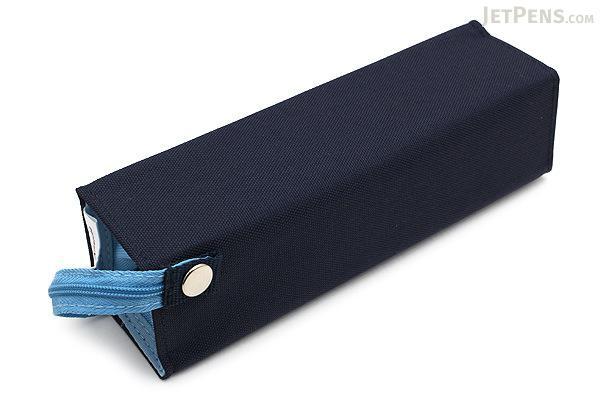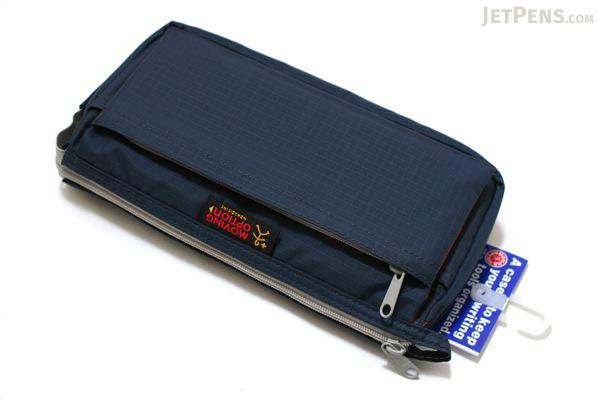The first image is the image on the left, the second image is the image on the right. Examine the images to the left and right. Is the description "An image shows just one pencil case, and it is solid sky blue in color." accurate? Answer yes or no. No. 